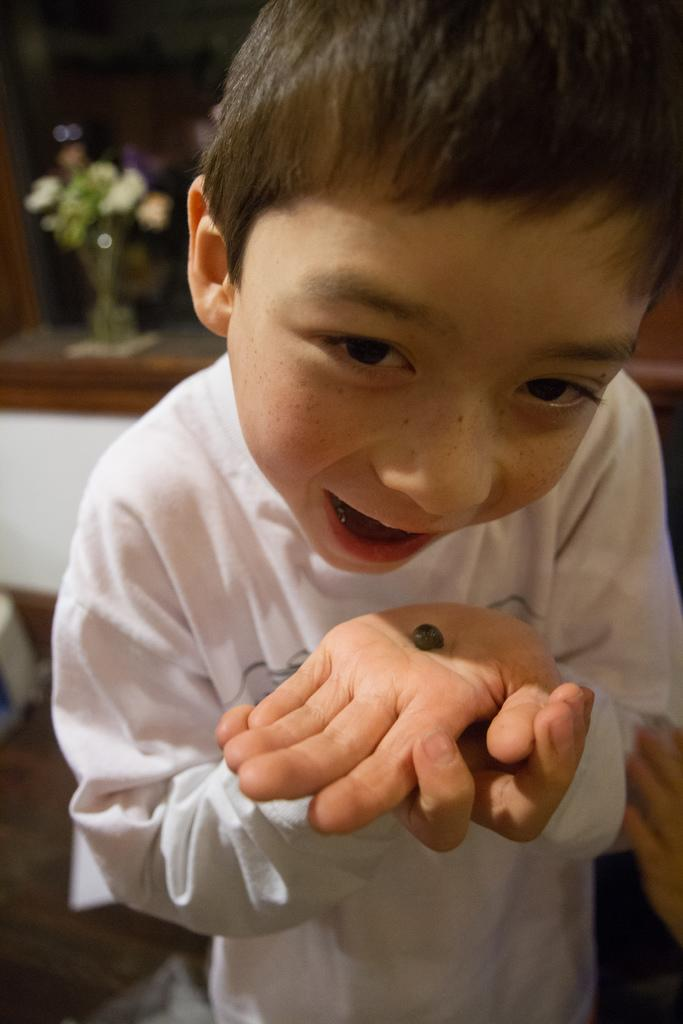What is the main subject of the image? The main subject of the image is a kid. What is the kid doing in the image? The kid is opening his mouth and looking at something. What is the kid holding in his palm? There is an object on the kid's palm. How would you describe the background of the image? The background of the image has a blurred view. Can you identify any other objects in the image? Yes, there is a flower vase in the image. What type of surface is visible in the image? There is a floor visible in the image. What type of protest is happening in the background of the image? There is no protest visible in the image; the background has a blurred view. Is the kid in the image standing in a cellar? There is no indication in the image that the kid is in a cellar; the floor visible in the image suggests a more typical indoor setting. Can you describe the earthquake that is happening in the image? There is no earthquake depicted in the image; the kid is simply opening his mouth and looking at something. 